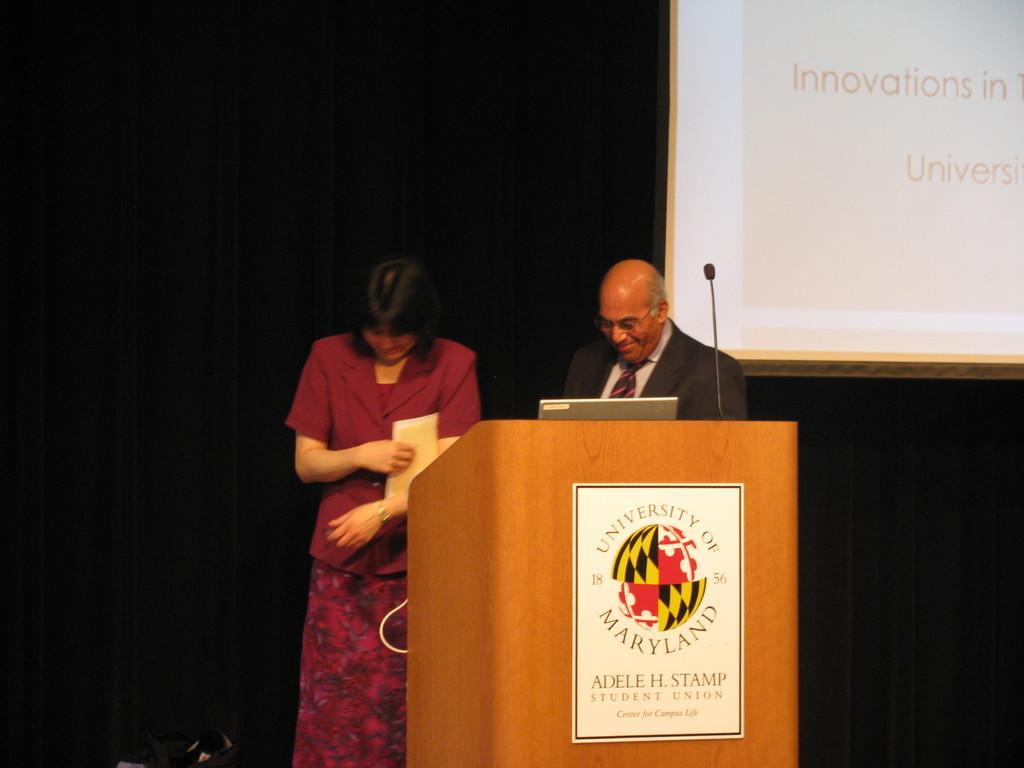Can you describe this image briefly? There is a man and a woman standing. Woman is holding something in the hand. There is a podium. On that there is a poster. Also there is a laptop and a mic on the podium. In the back it is dark. Also there is a screen. 